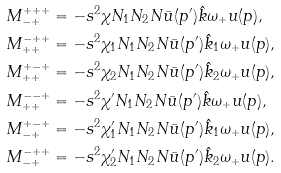Convert formula to latex. <formula><loc_0><loc_0><loc_500><loc_500>& M ^ { + + + } _ { - + } = - s ^ { 2 } \chi N _ { 1 } N _ { 2 } N \bar { u } ( p ^ { \prime } ) \hat { k } \omega _ { + } u ( p ) , \\ & M ^ { - + + } _ { + + } = - s ^ { 2 } \chi _ { 1 } N _ { 1 } N _ { 2 } N \bar { u } ( p ^ { \prime } ) \hat { k } _ { 1 } \omega _ { + } u ( p ) , \\ & M ^ { + - + } _ { + + } = - s ^ { 2 } \chi _ { 2 } N _ { 1 } N _ { 2 } N \bar { u } ( p ^ { \prime } ) \hat { k } _ { 2 } \omega _ { + } u ( p ) , \\ & M ^ { - - + } _ { + + } = - s ^ { 2 } \chi ^ { \prime } N _ { 1 } N _ { 2 } N \bar { u } ( p ^ { \prime } ) \hat { k } \omega _ { + } u ( p ) , \\ & M ^ { + - + } _ { - + } = - s ^ { 2 } \chi _ { 1 } ^ { \prime } N _ { 1 } N _ { 2 } N \bar { u } ( p ^ { \prime } ) \hat { k } _ { 1 } \omega _ { + } u ( p ) , \\ & M ^ { - + + } _ { - + } = - s ^ { 2 } \chi _ { 2 } ^ { \prime } N _ { 1 } N _ { 2 } N \bar { u } ( p ^ { \prime } ) \hat { k } _ { 2 } \omega _ { + } u ( p ) .</formula> 